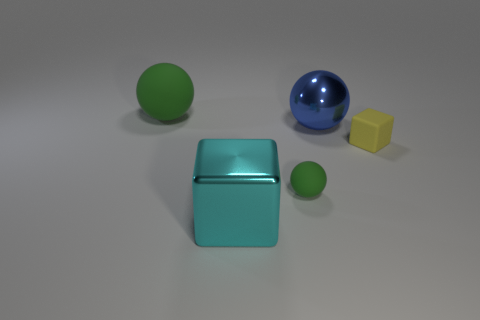There is a tiny object that is the same color as the large rubber sphere; what shape is it?
Provide a succinct answer. Sphere. Are there the same number of matte things on the right side of the big green rubber thing and big blue objects?
Your response must be concise. No. Do the large thing to the right of the cyan metal block and the green ball to the right of the large cyan thing have the same material?
Make the answer very short. No. How many objects are either small rubber objects or balls that are to the left of the large blue object?
Keep it short and to the point. 3. Are there any blue metallic things that have the same shape as the cyan shiny thing?
Offer a terse response. No. How big is the cube that is behind the green thing on the right side of the large ball that is on the left side of the big metallic sphere?
Keep it short and to the point. Small. Are there an equal number of large metallic objects that are behind the cyan metal block and cyan objects that are to the right of the yellow block?
Keep it short and to the point. No. The yellow object that is made of the same material as the big green ball is what size?
Your answer should be very brief. Small. The metal cube is what color?
Offer a terse response. Cyan. How many shiny objects have the same color as the rubber cube?
Your answer should be compact. 0. 